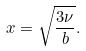<formula> <loc_0><loc_0><loc_500><loc_500>x = \sqrt { \frac { 3 \nu } { b } } .</formula> 